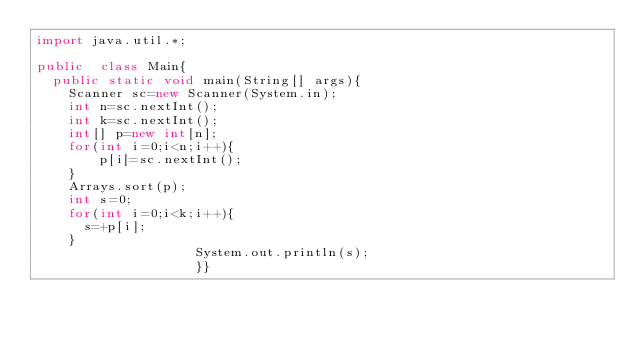<code> <loc_0><loc_0><loc_500><loc_500><_Java_>import java.util.*;
 
public  class Main{
  public static void main(String[] args){
    Scanner sc=new Scanner(System.in);
    int n=sc.nextInt();
    int k=sc.nextInt();
    int[] p=new int[n];
    for(int i=0;i<n;i++){
		p[i]=sc.nextInt();
    }
    Arrays.sort(p);
	int s=0;
    for(int i=0;i<k;i++){
      s=+p[i];
    }
                    System.out.println(s);
                    }}</code> 